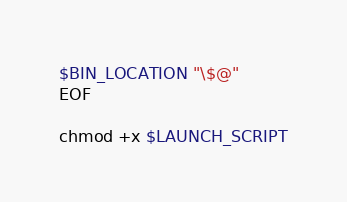<code> <loc_0><loc_0><loc_500><loc_500><_Bash_>$BIN_LOCATION "\$@"
EOF

chmod +x $LAUNCH_SCRIPT
</code> 